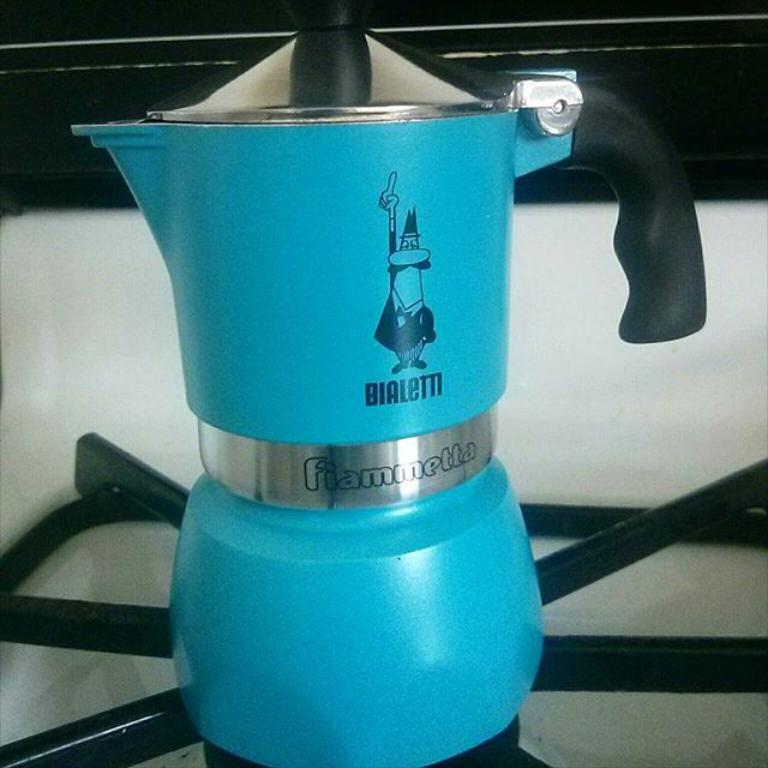<image>
Give a short and clear explanation of the subsequent image. A blue coffee pot has a small character over the word Bialetti. 